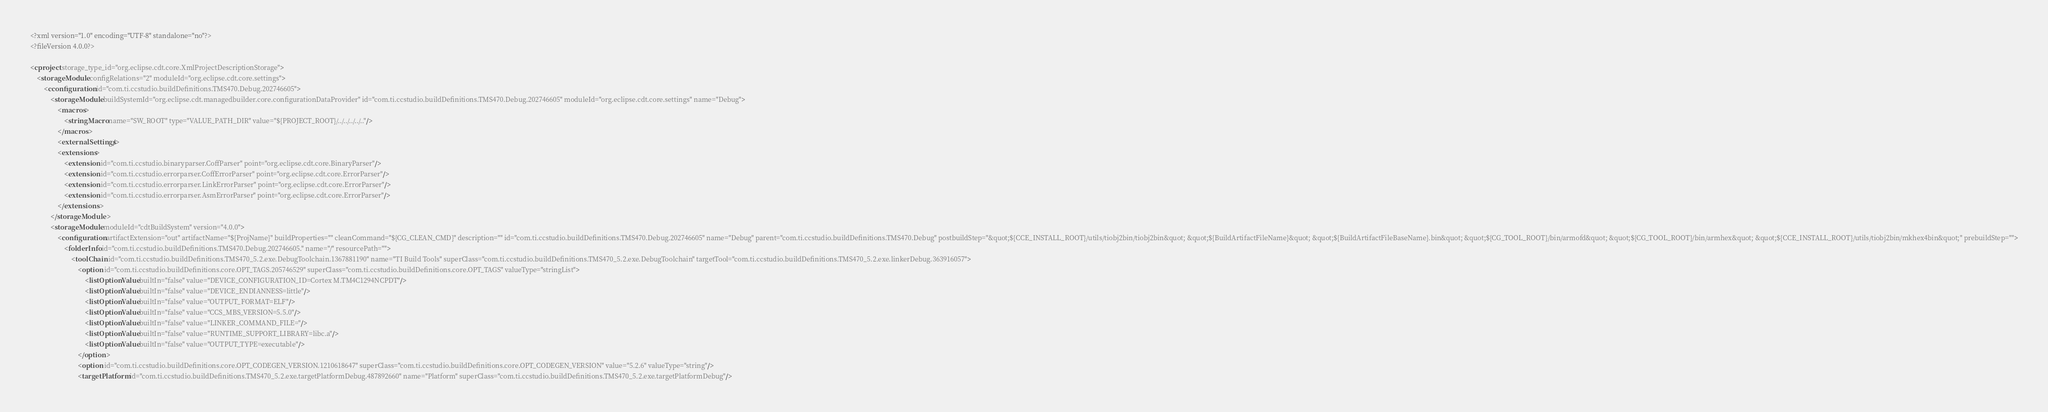Convert code to text. <code><loc_0><loc_0><loc_500><loc_500><_XML_><?xml version="1.0" encoding="UTF-8" standalone="no"?>
<?fileVersion 4.0.0?>

<cproject storage_type_id="org.eclipse.cdt.core.XmlProjectDescriptionStorage">
	<storageModule configRelations="2" moduleId="org.eclipse.cdt.core.settings">
		<cconfiguration id="com.ti.ccstudio.buildDefinitions.TMS470.Debug.202746605">
			<storageModule buildSystemId="org.eclipse.cdt.managedbuilder.core.configurationDataProvider" id="com.ti.ccstudio.buildDefinitions.TMS470.Debug.202746605" moduleId="org.eclipse.cdt.core.settings" name="Debug">
				<macros>
					<stringMacro name="SW_ROOT" type="VALUE_PATH_DIR" value="${PROJECT_ROOT}/../../../../.."/>
				</macros>
				<externalSettings/>
				<extensions>
					<extension id="com.ti.ccstudio.binaryparser.CoffParser" point="org.eclipse.cdt.core.BinaryParser"/>
					<extension id="com.ti.ccstudio.errorparser.CoffErrorParser" point="org.eclipse.cdt.core.ErrorParser"/>
					<extension id="com.ti.ccstudio.errorparser.LinkErrorParser" point="org.eclipse.cdt.core.ErrorParser"/>
					<extension id="com.ti.ccstudio.errorparser.AsmErrorParser" point="org.eclipse.cdt.core.ErrorParser"/>
				</extensions>
			</storageModule>
			<storageModule moduleId="cdtBuildSystem" version="4.0.0">
				<configuration artifactExtension="out" artifactName="${ProjName}" buildProperties="" cleanCommand="${CG_CLEAN_CMD}" description="" id="com.ti.ccstudio.buildDefinitions.TMS470.Debug.202746605" name="Debug" parent="com.ti.ccstudio.buildDefinitions.TMS470.Debug" postbuildStep="&quot;${CCE_INSTALL_ROOT}/utils/tiobj2bin/tiobj2bin&quot; &quot;${BuildArtifactFileName}&quot; &quot;${BuildArtifactFileBaseName}.bin&quot; &quot;${CG_TOOL_ROOT}/bin/armofd&quot; &quot;${CG_TOOL_ROOT}/bin/armhex&quot; &quot;${CCE_INSTALL_ROOT}/utils/tiobj2bin/mkhex4bin&quot;" prebuildStep="">
					<folderInfo id="com.ti.ccstudio.buildDefinitions.TMS470.Debug.202746605." name="/" resourcePath="">
						<toolChain id="com.ti.ccstudio.buildDefinitions.TMS470_5.2.exe.DebugToolchain.1367881190" name="TI Build Tools" superClass="com.ti.ccstudio.buildDefinitions.TMS470_5.2.exe.DebugToolchain" targetTool="com.ti.ccstudio.buildDefinitions.TMS470_5.2.exe.linkerDebug.363916057">
							<option id="com.ti.ccstudio.buildDefinitions.core.OPT_TAGS.205746529" superClass="com.ti.ccstudio.buildDefinitions.core.OPT_TAGS" valueType="stringList">
								<listOptionValue builtIn="false" value="DEVICE_CONFIGURATION_ID=Cortex M.TM4C1294NCPDT"/>
								<listOptionValue builtIn="false" value="DEVICE_ENDIANNESS=little"/>
								<listOptionValue builtIn="false" value="OUTPUT_FORMAT=ELF"/>
								<listOptionValue builtIn="false" value="CCS_MBS_VERSION=5.5.0"/>
								<listOptionValue builtIn="false" value="LINKER_COMMAND_FILE="/>
								<listOptionValue builtIn="false" value="RUNTIME_SUPPORT_LIBRARY=libc.a"/>
								<listOptionValue builtIn="false" value="OUTPUT_TYPE=executable"/>
							</option>
							<option id="com.ti.ccstudio.buildDefinitions.core.OPT_CODEGEN_VERSION.1210618647" superClass="com.ti.ccstudio.buildDefinitions.core.OPT_CODEGEN_VERSION" value="5.2.6" valueType="string"/>
							<targetPlatform id="com.ti.ccstudio.buildDefinitions.TMS470_5.2.exe.targetPlatformDebug.487892660" name="Platform" superClass="com.ti.ccstudio.buildDefinitions.TMS470_5.2.exe.targetPlatformDebug"/></code> 